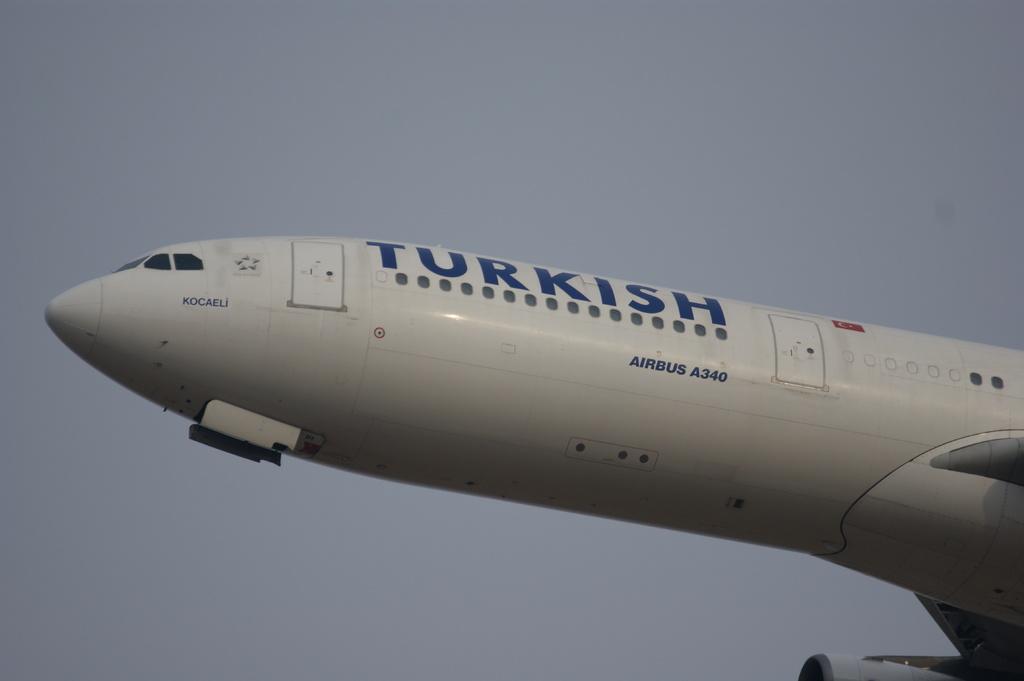What is the name in blue on the plane?
Your answer should be compact. Turkish. 